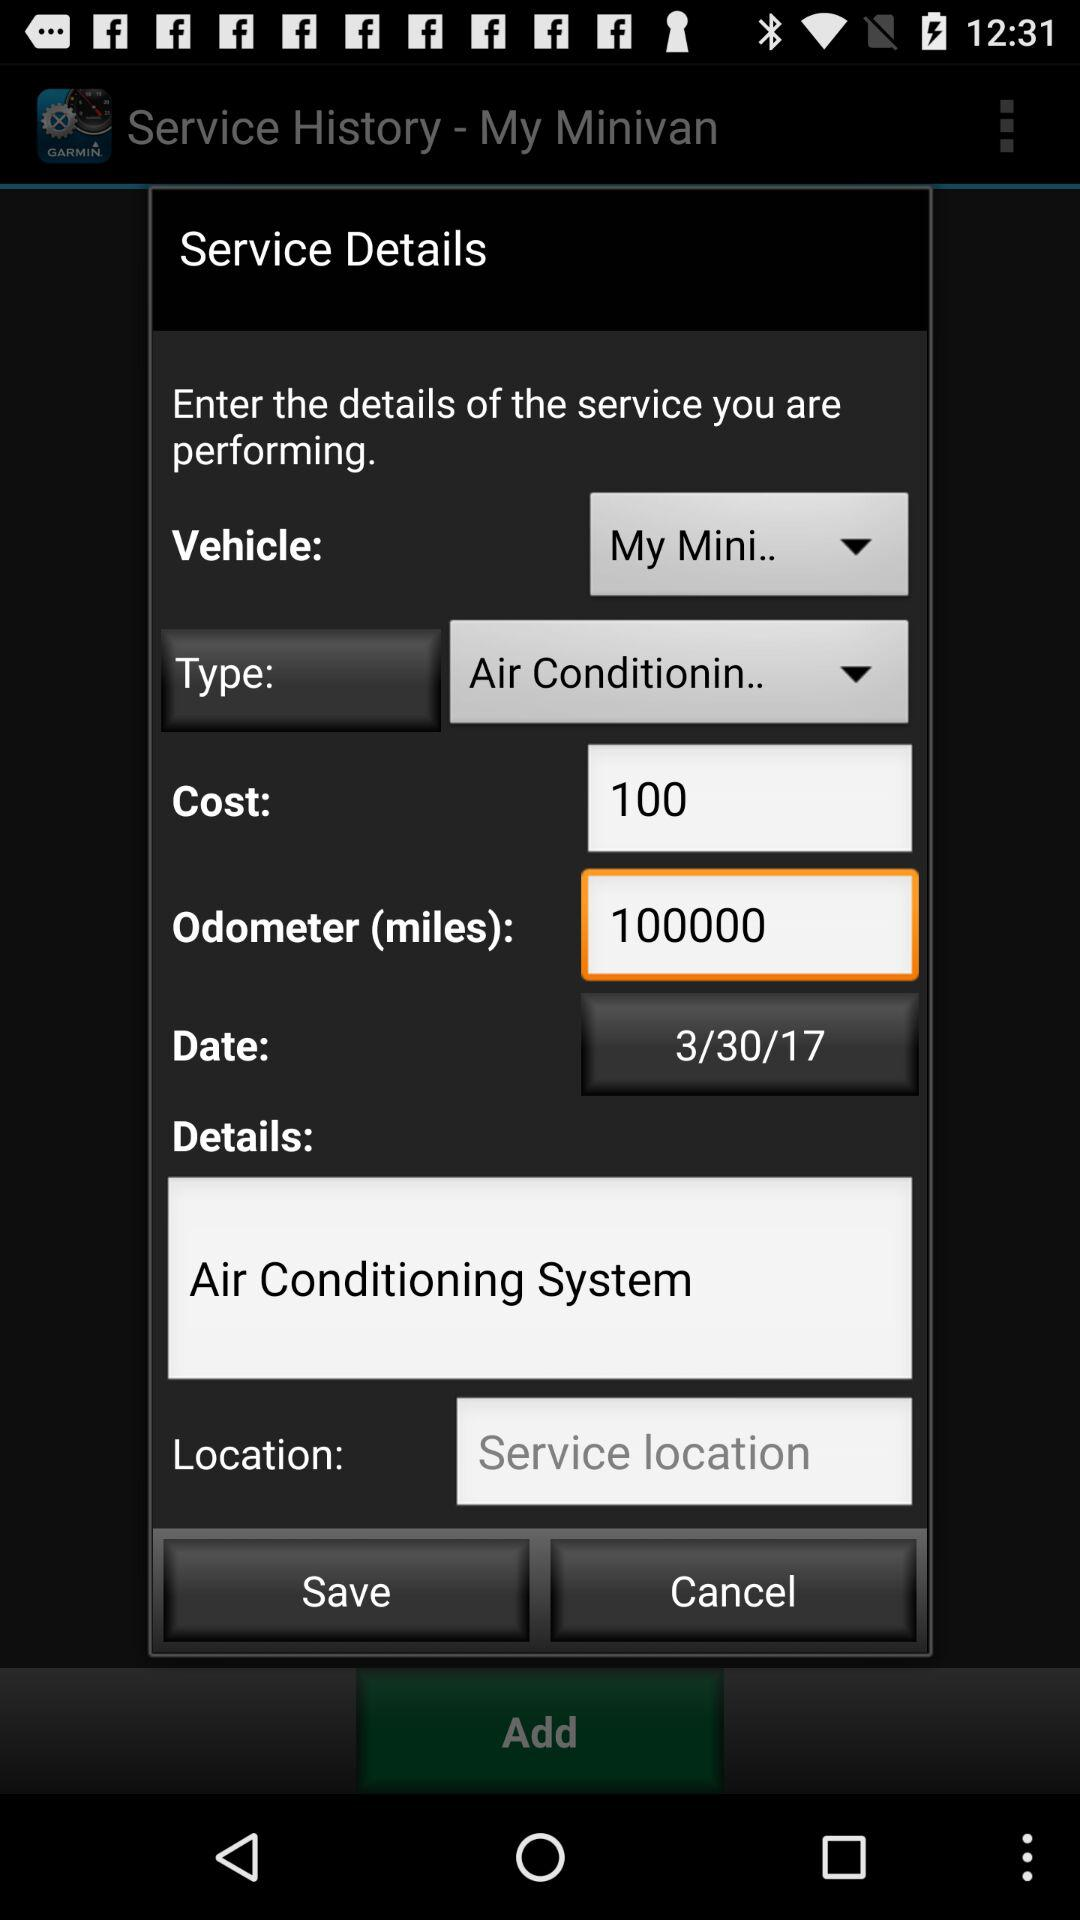What is the selected date? The selected date is March 30, 2017. 